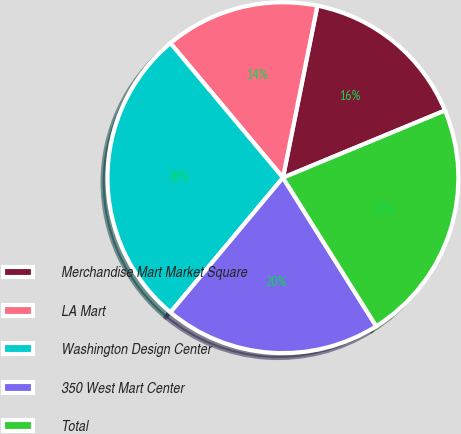Convert chart to OTSL. <chart><loc_0><loc_0><loc_500><loc_500><pie_chart><fcel>Merchandise Mart Market Square<fcel>LA Mart<fcel>Washington Design Center<fcel>350 West Mart Center<fcel>Total<nl><fcel>15.6%<fcel>14.23%<fcel>27.84%<fcel>20.0%<fcel>22.33%<nl></chart> 